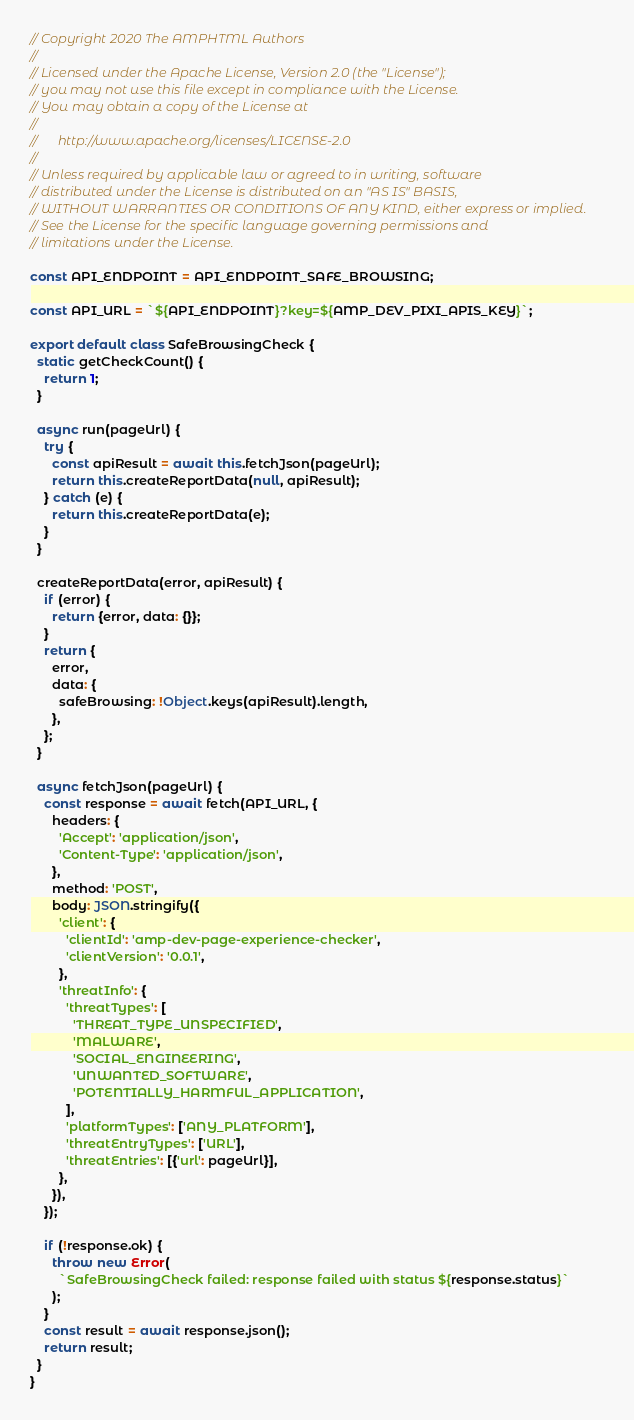Convert code to text. <code><loc_0><loc_0><loc_500><loc_500><_JavaScript_>// Copyright 2020 The AMPHTML Authors
//
// Licensed under the Apache License, Version 2.0 (the "License");
// you may not use this file except in compliance with the License.
// You may obtain a copy of the License at
//
//      http://www.apache.org/licenses/LICENSE-2.0
//
// Unless required by applicable law or agreed to in writing, software
// distributed under the License is distributed on an "AS IS" BASIS,
// WITHOUT WARRANTIES OR CONDITIONS OF ANY KIND, either express or implied.
// See the License for the specific language governing permissions and
// limitations under the License.

const API_ENDPOINT = API_ENDPOINT_SAFE_BROWSING;

const API_URL = `${API_ENDPOINT}?key=${AMP_DEV_PIXI_APIS_KEY}`;

export default class SafeBrowsingCheck {
  static getCheckCount() {
    return 1;
  }

  async run(pageUrl) {
    try {
      const apiResult = await this.fetchJson(pageUrl);
      return this.createReportData(null, apiResult);
    } catch (e) {
      return this.createReportData(e);
    }
  }

  createReportData(error, apiResult) {
    if (error) {
      return {error, data: {}};
    }
    return {
      error,
      data: {
        safeBrowsing: !Object.keys(apiResult).length,
      },
    };
  }

  async fetchJson(pageUrl) {
    const response = await fetch(API_URL, {
      headers: {
        'Accept': 'application/json',
        'Content-Type': 'application/json',
      },
      method: 'POST',
      body: JSON.stringify({
        'client': {
          'clientId': 'amp-dev-page-experience-checker',
          'clientVersion': '0.0.1',
        },
        'threatInfo': {
          'threatTypes': [
            'THREAT_TYPE_UNSPECIFIED',
            'MALWARE',
            'SOCIAL_ENGINEERING',
            'UNWANTED_SOFTWARE',
            'POTENTIALLY_HARMFUL_APPLICATION',
          ],
          'platformTypes': ['ANY_PLATFORM'],
          'threatEntryTypes': ['URL'],
          'threatEntries': [{'url': pageUrl}],
        },
      }),
    });

    if (!response.ok) {
      throw new Error(
        `SafeBrowsingCheck failed: response failed with status ${response.status}`
      );
    }
    const result = await response.json();
    return result;
  }
}
</code> 